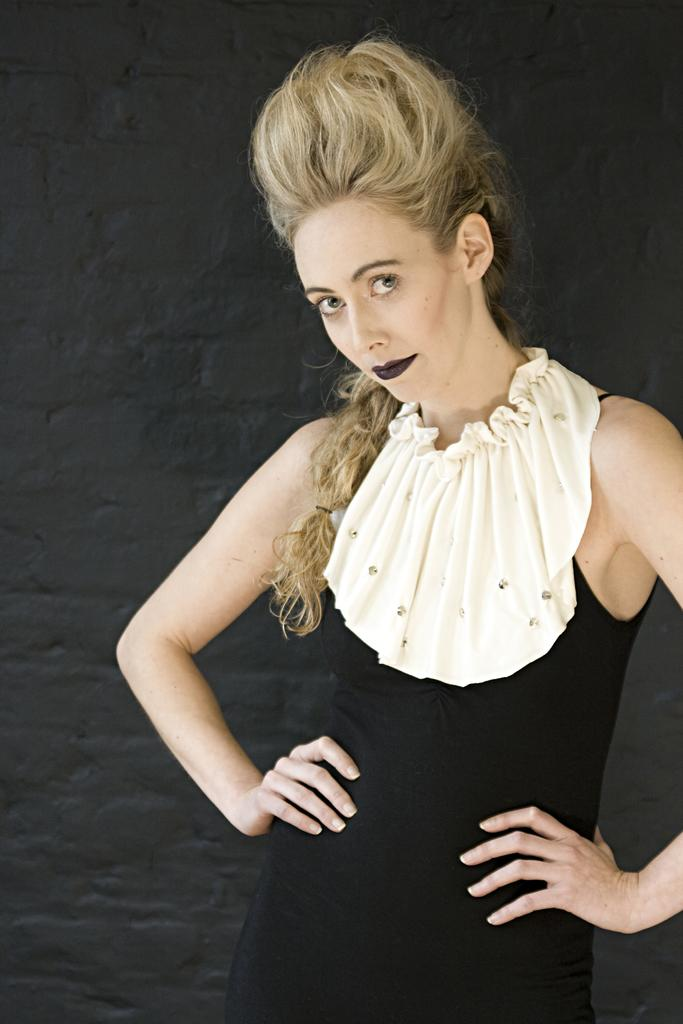What is the main subject of the image? There is a girl standing in the image. What can be seen in the background of the image? There is a wall in the background of the image. Can you see a road in the image? No, there is no road visible in the image. Are the girl and another person kissing in the image? No, there is no kissing depicted in the image. 